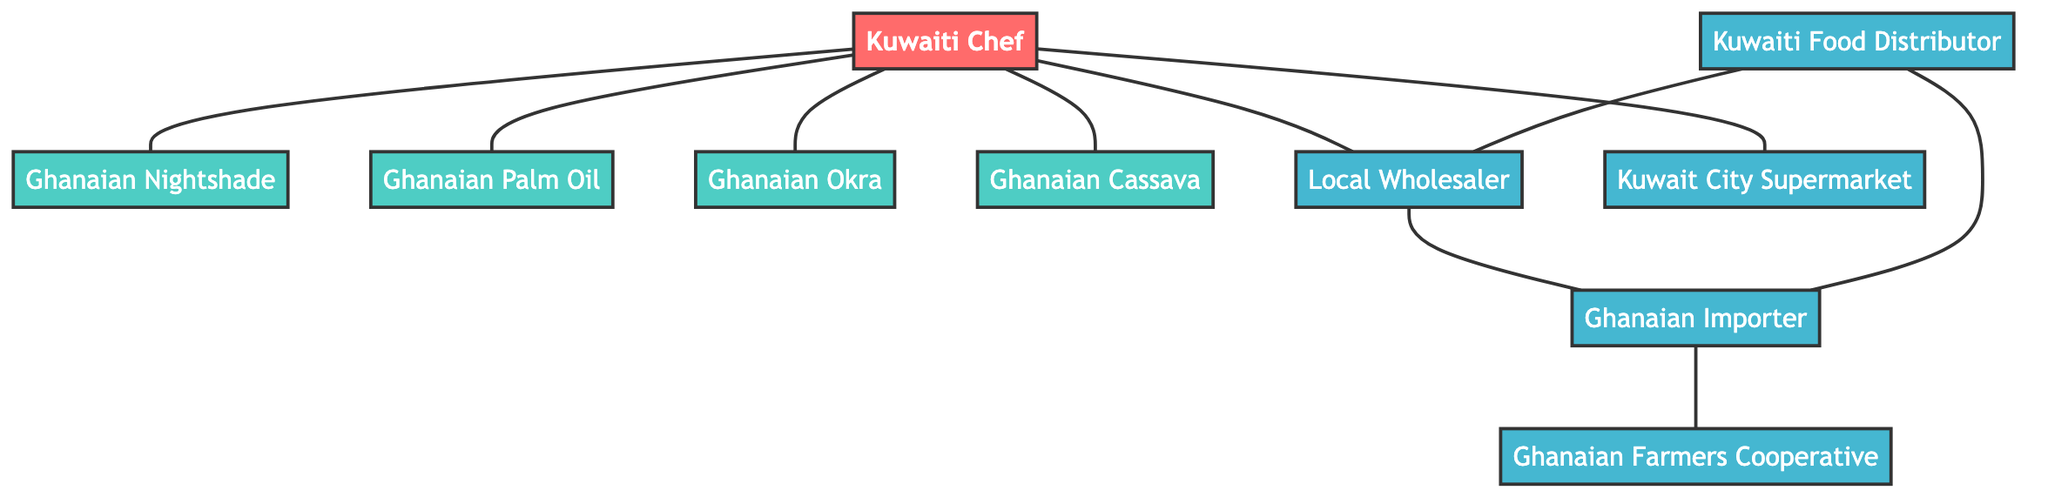What is the total number of nodes in the diagram? The diagram lists ten distinct nodes including the Kuwaiti Chef, various Ghanaian ingredients, and suppliers like Local Wholesaler, Ghanaian Importer, Kuwait City Supermarket, Ghanaian Farmers Cooperative, and Kuwaiti Food Distributor. Counting these gives a total of 10 nodes.
Answer: 10 Which supplier is directly connected to the Kuwaiti Chef? The edges directly connected to the Kuwaiti Chef are with Local Wholesaler and Kuwait City Supermarket. Thus, both are suppliers directly related to the Kuwaiti Chef.
Answer: Local Wholesaler, Kuwait City Supermarket How many ingredients does the Kuwaiti Chef purchase directly? From the diagram, the Kuwaiti Chef is directly connected to Ghanaian Nightshade, Ghanaian Palm Oil, Ghanaian Okra, and Ghanaian Cassava. This gives a total of 4 ingredients.
Answer: 4 What is the relationship between the Local Wholesaler and the Ghanaian Importer? The Local Wholesaler has a direct edge connecting it to the Ghanaian Importer, indicating a supplier relationship. This means the Local Wholesaler sources products from the Ghanaian Importer.
Answer: Supplier relationship Which entity connects the Local Wholesaler and the Ghanaian Farmers Cooperative? The diagram shows that the Local Wholesaler connects to the Ghanaian Importer, which then connects to the Ghanaian Farmers Cooperative. Therefore, the Ghanaian Importer is the entity that connects them.
Answer: Ghanaian Importer How many edges are present in the diagram? An edge is a connection between two nodes. By counting the edges between the various nodes in the diagram, we find there are 8 edges linking the nodes.
Answer: 8 What is the shortest path from the Kuwaiti Chef to the Ghanaian Farmers Cooperative? The path involves moving from the Kuwaiti Chef to the Local Wholesaler, then to the Ghanaian Importer, and finally to the Ghanaian Farmers Cooperative, making the shortest path 3 steps long.
Answer: 3 steps Which ingredient does not have a direct connection to the Kuwaiti Food Distributor? The Kuwaiti Food Distributor is connected to the Local Wholesaler and the Ghanaian Importer, but does not have a direct connection to any of the ingredients including Ghanaian Nightshade, Ghanaian Palm Oil, Ghanaian Okra, and Ghanaian Cassava. Thus, all the ingredients lack a direct connection.
Answer: All ingredients 